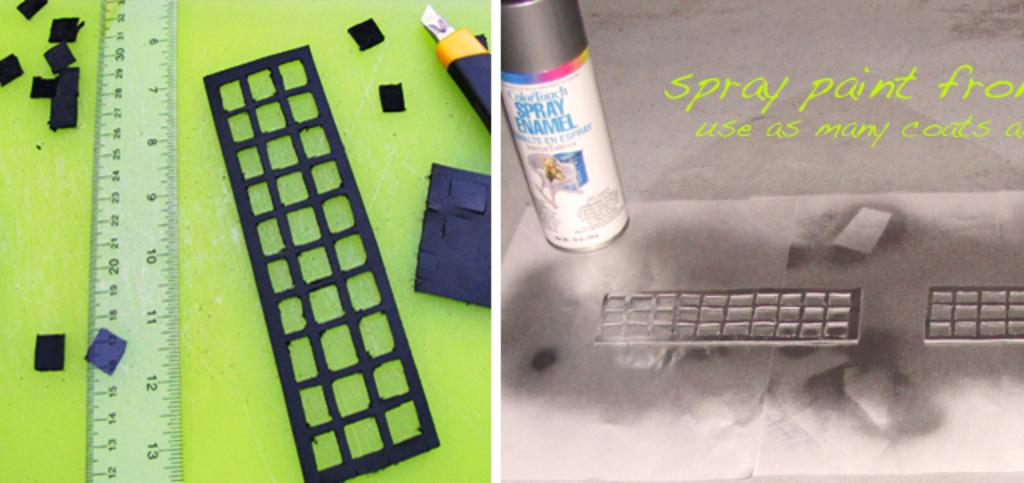<image>
Offer a succinct explanation of the picture presented. The picture of the right shows a tin and talks about spray paint. 